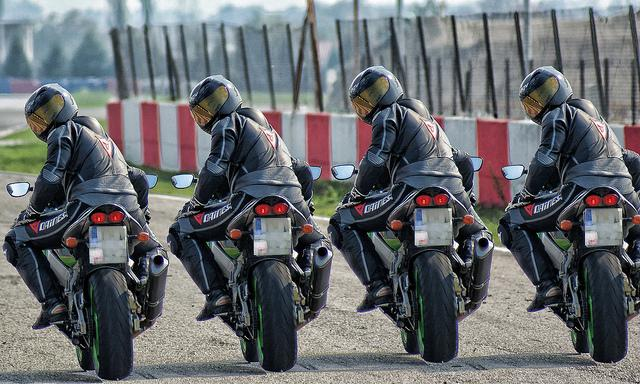What are the motorcycles riding on? track 